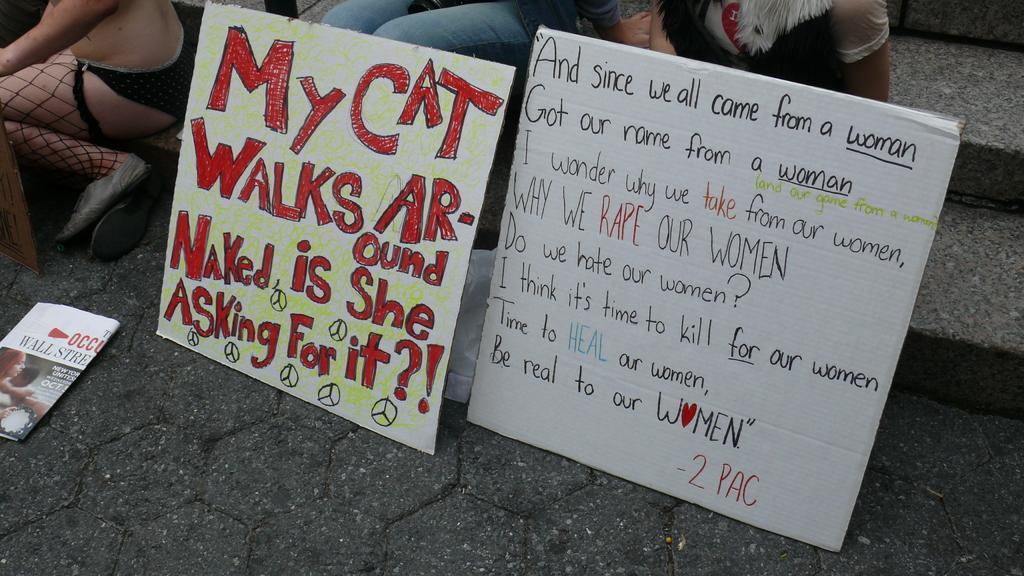Please provide a concise description of this image. In this picture, we see the cardboards in white color with some text written on it. At the bottom, we see the pavement. Behind the boards, we see a white cover and two people are sitting on the staircase. On the left side, we see a newspaper. In the left top, we see a person is sitting on the staircase and we see a frame. 